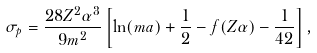Convert formula to latex. <formula><loc_0><loc_0><loc_500><loc_500>\sigma _ { p } = \frac { 2 8 Z ^ { 2 } \alpha ^ { 3 } } { 9 m ^ { 2 } } \left [ \ln ( m a ) + \frac { 1 } { 2 } - f ( Z \alpha ) - \frac { 1 } { 4 2 } \right ] ,</formula> 